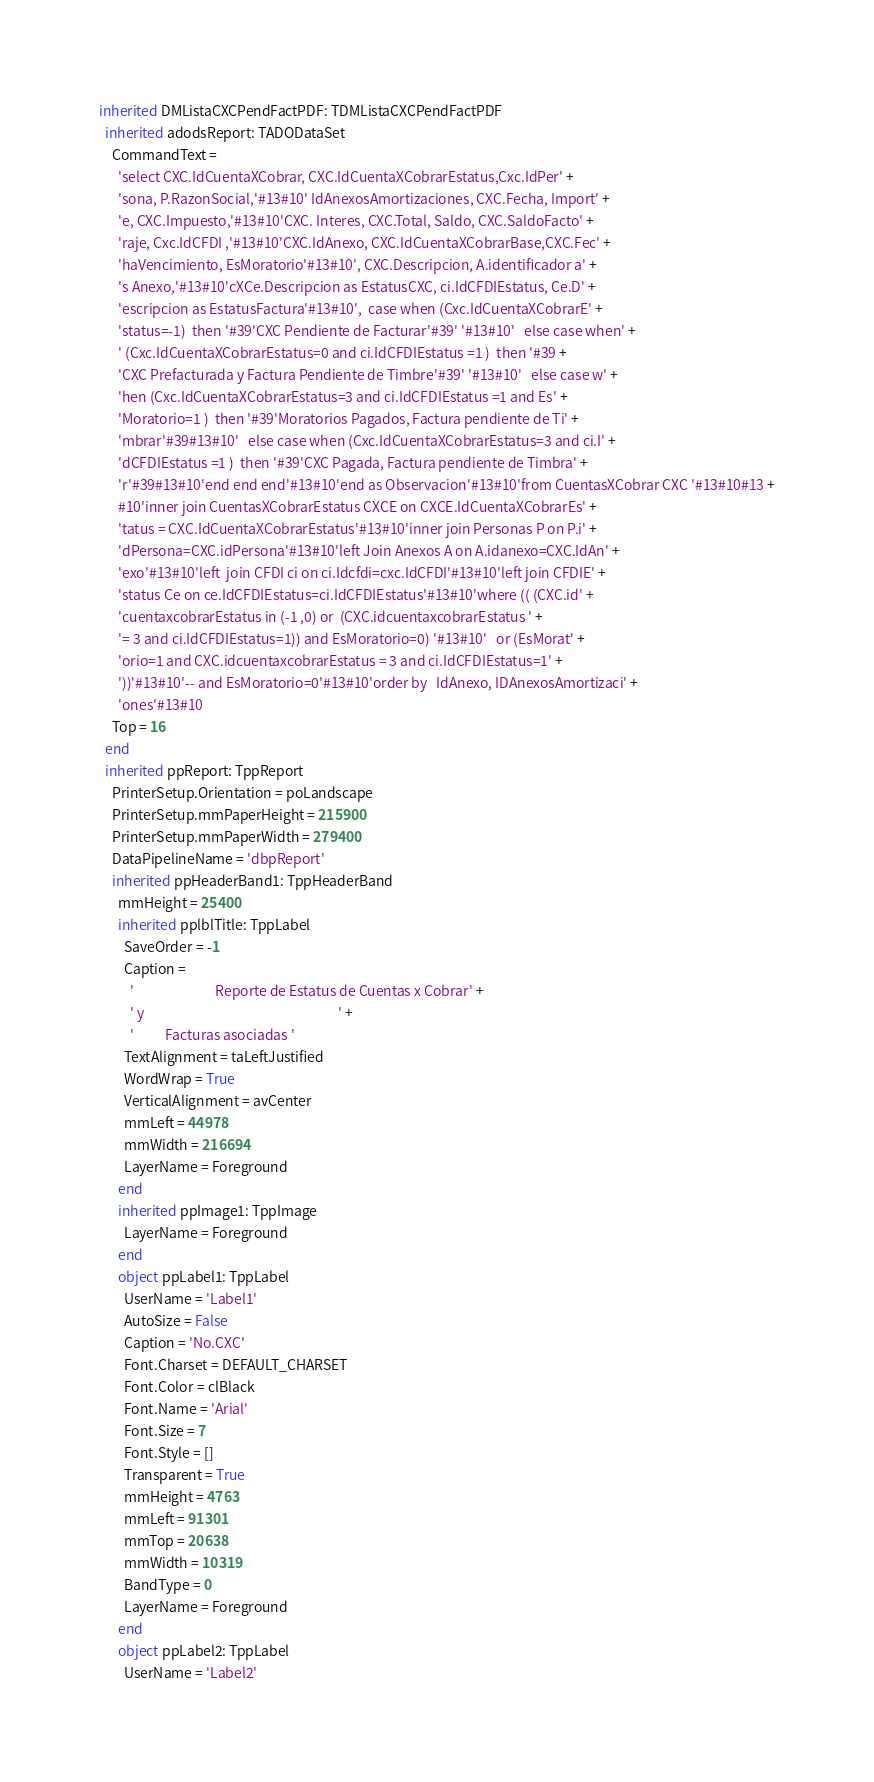Convert code to text. <code><loc_0><loc_0><loc_500><loc_500><_Pascal_>inherited DMListaCXCPendFactPDF: TDMListaCXCPendFactPDF
  inherited adodsReport: TADODataSet
    CommandText = 
      'select CXC.IdCuentaXCobrar, CXC.IdCuentaXCobrarEstatus,Cxc.IdPer' +
      'sona, P.RazonSocial,'#13#10' IdAnexosAmortizaciones, CXC.Fecha, Import' +
      'e, CXC.Impuesto,'#13#10'CXC. Interes, CXC.Total, Saldo, CXC.SaldoFacto' +
      'raje, Cxc.IdCFDI ,'#13#10'CXC.IdAnexo, CXC.IdCuentaXCobrarBase,CXC.Fec' +
      'haVencimiento, EsMoratorio'#13#10', CXC.Descripcion, A.identificador a' +
      's Anexo,'#13#10'cXCe.Descripcion as EstatusCXC, ci.IdCFDIEstatus, Ce.D' +
      'escripcion as EstatusFactura'#13#10',  case when (Cxc.IdCuentaXCobrarE' +
      'status=-1)  then '#39'CXC Pendiente de Facturar'#39' '#13#10'   else case when' +
      ' (Cxc.IdCuentaXCobrarEstatus=0 and ci.IdCFDIEstatus =1 )  then '#39 +
      'CXC Prefacturada y Factura Pendiente de Timbre'#39' '#13#10'   else case w' +
      'hen (Cxc.IdCuentaXCobrarEstatus=3 and ci.IdCFDIEstatus =1 and Es' +
      'Moratorio=1 )  then '#39'Moratorios Pagados, Factura pendiente de Ti' +
      'mbrar'#39#13#10'   else case when (Cxc.IdCuentaXCobrarEstatus=3 and ci.I' +
      'dCFDIEstatus =1 )  then '#39'CXC Pagada, Factura pendiente de Timbra' +
      'r'#39#13#10'end end end'#13#10'end as Observacion'#13#10'from CuentasXCobrar CXC '#13#10#13 +
      #10'inner join CuentasXCobrarEstatus CXCE on CXCE.IdCuentaXCobrarEs' +
      'tatus = CXC.IdCuentaXCobrarEstatus'#13#10'inner join Personas P on P.i' +
      'dPersona=CXC.idPersona'#13#10'left Join Anexos A on A.idanexo=CXC.IdAn' +
      'exo'#13#10'left  join CFDI ci on ci.Idcfdi=cxc.IdCFDI'#13#10'left join CFDIE' +
      'status Ce on ce.IdCFDIEstatus=ci.IdCFDIEstatus'#13#10'where (( (CXC.id' +
      'cuentaxcobrarEstatus in (-1 ,0) or  (CXC.idcuentaxcobrarEstatus ' +
      '= 3 and ci.IdCFDIEstatus=1)) and EsMoratorio=0) '#13#10'   or (EsMorat' +
      'orio=1 and CXC.idcuentaxcobrarEstatus = 3 and ci.IdCFDIEstatus=1' +
      '))'#13#10'-- and EsMoratorio=0'#13#10'order by   IdAnexo, IDAnexosAmortizaci' +
      'ones'#13#10
    Top = 16
  end
  inherited ppReport: TppReport
    PrinterSetup.Orientation = poLandscape
    PrinterSetup.mmPaperHeight = 215900
    PrinterSetup.mmPaperWidth = 279400
    DataPipelineName = 'dbpReport'
    inherited ppHeaderBand1: TppHeaderBand
      mmHeight = 25400
      inherited pplblTitle: TppLabel
        SaveOrder = -1
        Caption = 
          '                          Reporte de Estatus de Cuentas x Cobrar' +
          ' y                                                              ' +
          '          Facturas asociadas '
        TextAlignment = taLeftJustified
        WordWrap = True
        VerticalAlignment = avCenter
        mmLeft = 44978
        mmWidth = 216694
        LayerName = Foreground
      end
      inherited ppImage1: TppImage
        LayerName = Foreground
      end
      object ppLabel1: TppLabel
        UserName = 'Label1'
        AutoSize = False
        Caption = 'No.CXC'
        Font.Charset = DEFAULT_CHARSET
        Font.Color = clBlack
        Font.Name = 'Arial'
        Font.Size = 7
        Font.Style = []
        Transparent = True
        mmHeight = 4763
        mmLeft = 91301
        mmTop = 20638
        mmWidth = 10319
        BandType = 0
        LayerName = Foreground
      end
      object ppLabel2: TppLabel
        UserName = 'Label2'</code> 